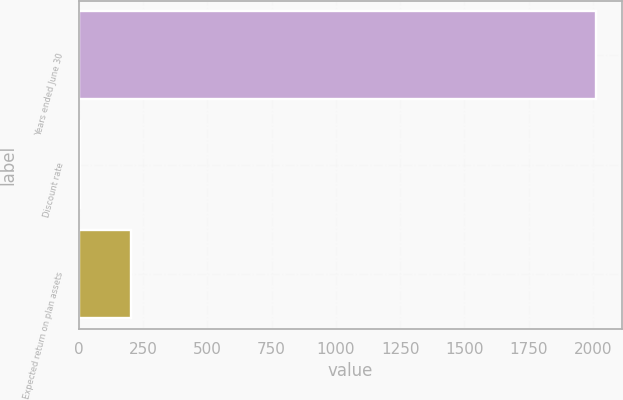Convert chart. <chart><loc_0><loc_0><loc_500><loc_500><bar_chart><fcel>Years ended June 30<fcel>Discount rate<fcel>Expected return on plan assets<nl><fcel>2012<fcel>4.3<fcel>205.07<nl></chart> 